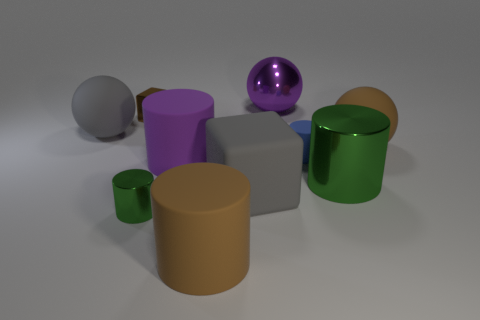There is a big brown object that is to the left of the blue rubber cylinder; what number of green metallic cylinders are to the left of it?
Your answer should be compact. 1. There is a rubber ball to the left of the big purple cylinder; is it the same color as the metal cylinder that is behind the large gray matte block?
Ensure brevity in your answer.  No. What material is the green cylinder that is the same size as the purple shiny thing?
Your answer should be very brief. Metal. What shape is the gray matte thing that is in front of the large purple object in front of the big brown rubber ball on the right side of the blue thing?
Ensure brevity in your answer.  Cube. The purple shiny object that is the same size as the gray ball is what shape?
Your answer should be compact. Sphere. How many tiny rubber things are in front of the green metallic object that is on the left side of the tiny cylinder to the right of the metal ball?
Your answer should be very brief. 0. Is the number of green metal objects in front of the gray ball greater than the number of tiny rubber things that are left of the purple shiny sphere?
Offer a very short reply. Yes. How many big purple things have the same shape as the small blue rubber thing?
Provide a short and direct response. 1. How many objects are big things that are in front of the brown shiny thing or big matte cylinders that are behind the large brown cylinder?
Offer a very short reply. 6. The big brown thing that is behind the cube that is in front of the gray rubber object to the left of the brown block is made of what material?
Your response must be concise. Rubber. 